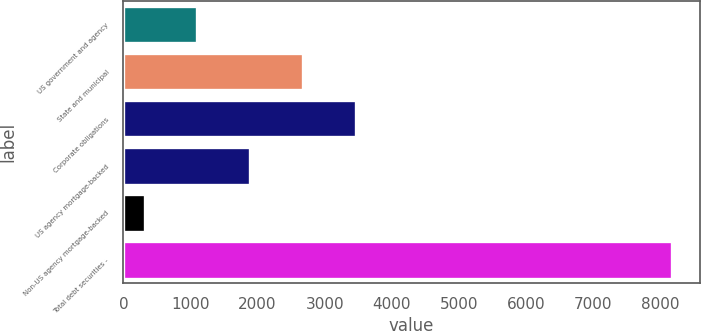<chart> <loc_0><loc_0><loc_500><loc_500><bar_chart><fcel>US government and agency<fcel>State and municipal<fcel>Corporate obligations<fcel>US agency mortgage-backed<fcel>Non-US agency mortgage-backed<fcel>Total debt securities -<nl><fcel>1101.5<fcel>2674.5<fcel>3461<fcel>1888<fcel>315<fcel>8180<nl></chart> 